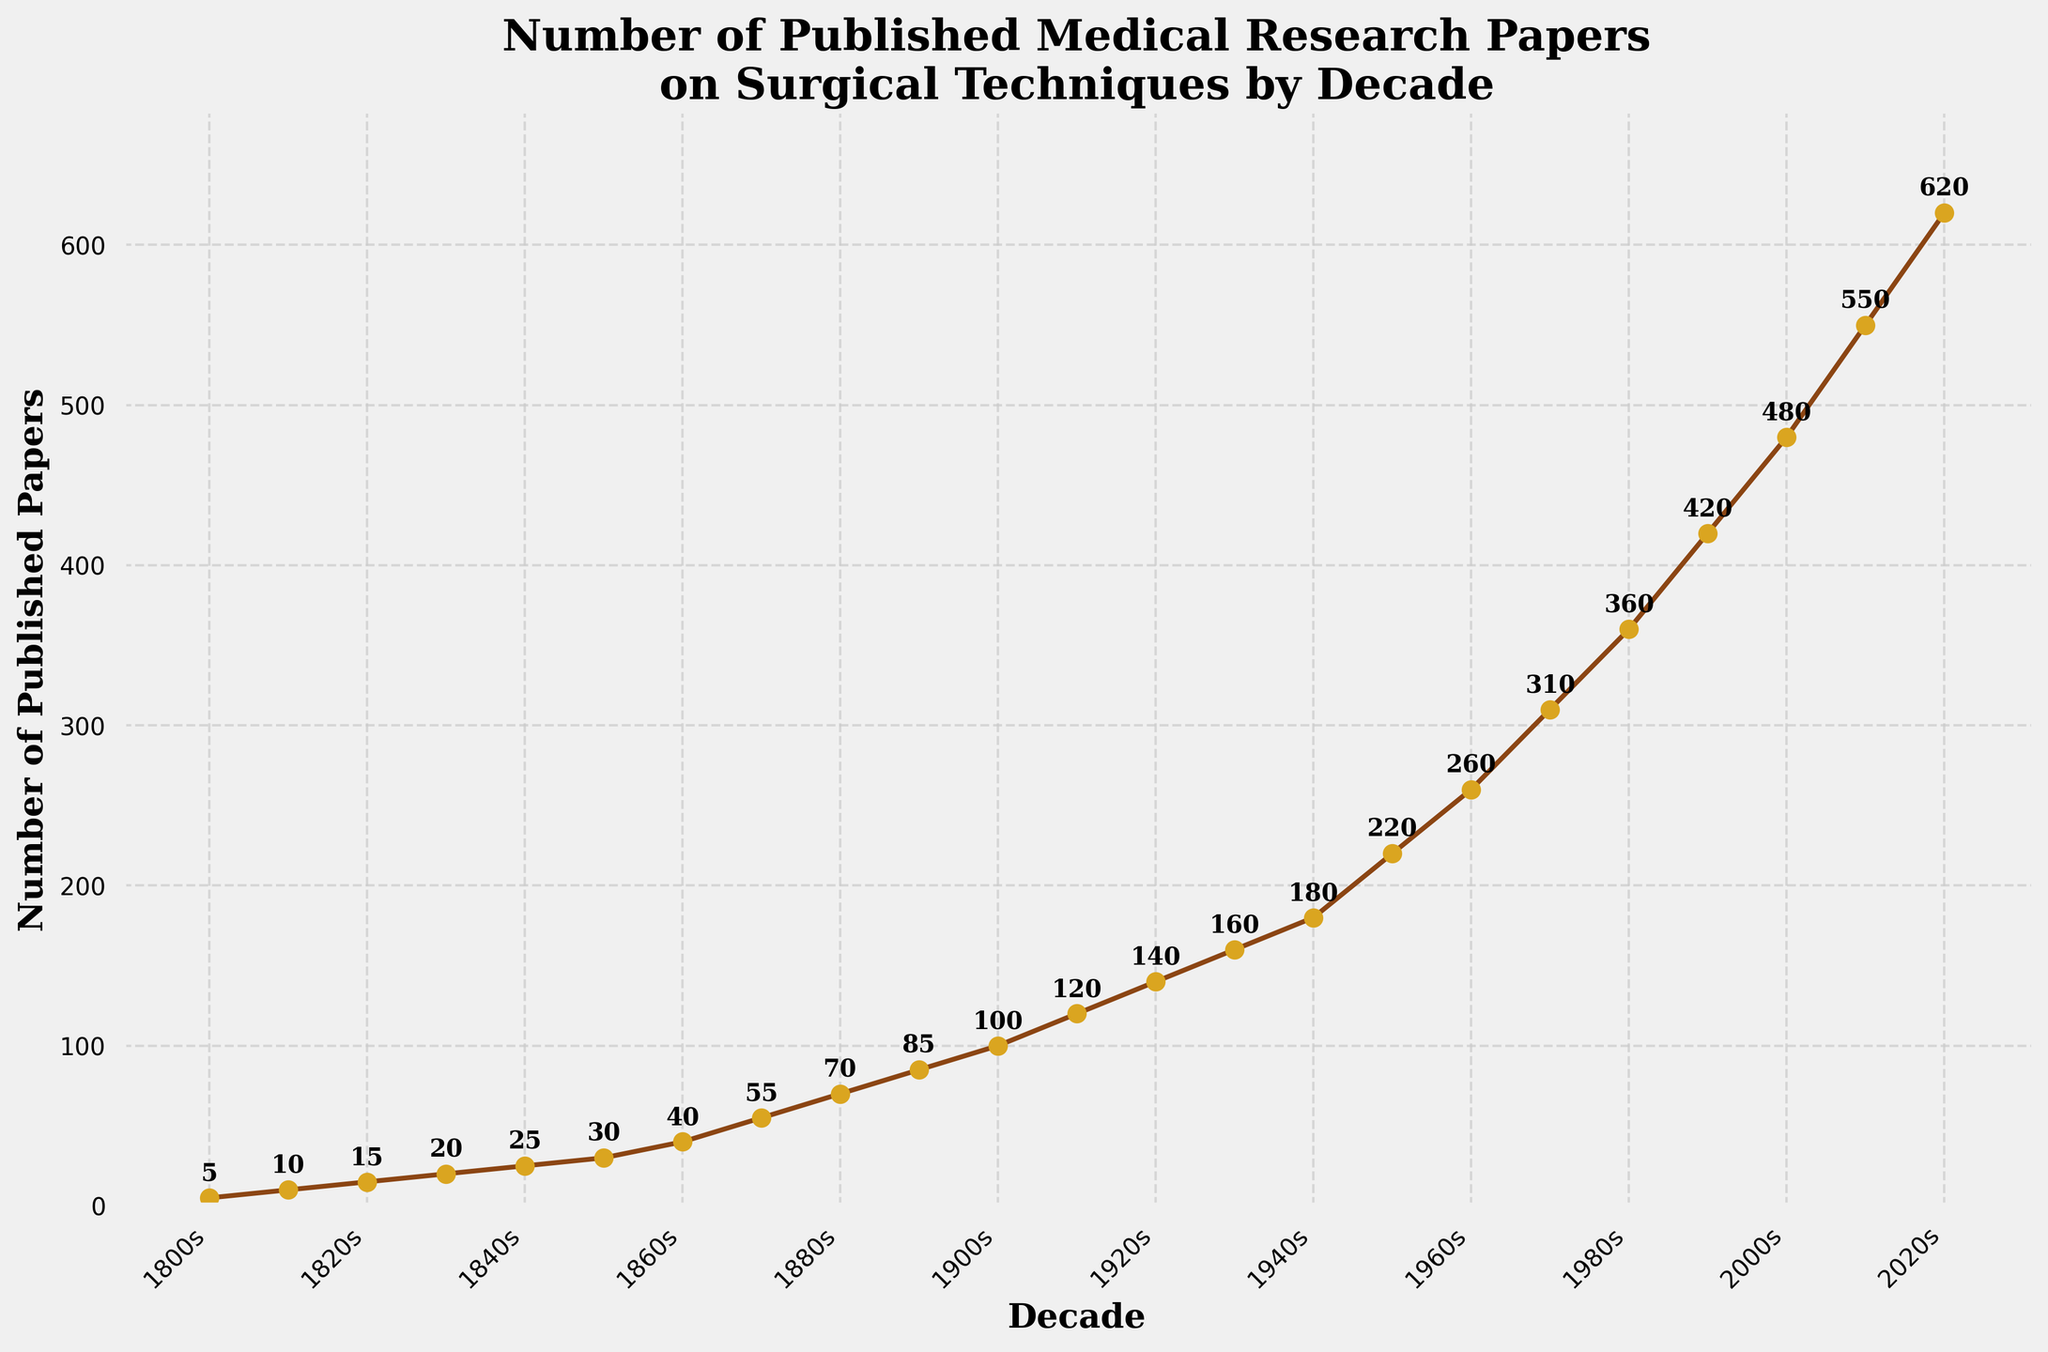What is the title of the figure? The title of the figure is displayed at the top and provides an overview of the visualization's content. It says "Number of Published Medical Research Papers on Surgical Techniques by Decade".
Answer: Number of Published Medical Research Papers on Surgical Techniques by Decade How does the number of published papers in the 1860s compare to the 1880s? In the 1860s, there were 40 published papers, and in the 1880s, there were 70. Subtracting the number in the 1860s from the 1880s gives 70 - 40 = 30 more papers published in the 1880s.
Answer: 30 more papers What is the trend in the number of published medical research papers from 1800 to 2020? The graph shows a steady increase in the number of published papers over the decades, indicating a consistent upward trend.
Answer: Upward trend In which decade did the number of published papers first exceed 100? By checking the graph, the number of published papers first exceeds 100 in the 1900s, where it reaches 100 papers exactly.
Answer: 1900s What was the total number of papers published from 1860s to 1920s? Summing the number of published papers from the 1860s (40), 1870s (55), 1880s (70), 1890s (85), 1900s (100), 1910s (120), and 1920s (140) gives 40 + 55 + 70 + 85 + 100 + 120 + 140 = 610.
Answer: 610 During which decade was there the greatest increase in the number of papers published compared to the previous decade? By calculating the differences for each decade and comparing them, the largest increase is found between the 2010s (550 papers) and the 2020s (620 papers), a difference of 620 - 550 = 70 papers.
Answer: 2010s to 2020s What is the difference in the number of papers published between the 1950s and 1970s? The number of papers in the 1950s is 220 and in the 1970s is 310. The difference is 310 - 220 = 90 papers.
Answer: 90 papers How many times more papers were published in the 2000s compared to the 1800s? There were 480 papers published in the 2000s and 5 in the 1800s. The multiplication factor is 480 / 5 = 96 times more papers.
Answer: 96 times What is the average number of papers published per decade from 1800s to 2020s? Summing the total number of published papers (sum of all values from 1800s to 2020s: 5 + 10 + 15 + 20 + 25 + 30 + 40 + 55 + 70 + 85 + 100 + 120 + 140 + 160 + 180 + 220 + 260 + 310 + 360 + 420 + 480 + 550 + 620 = 4275). Since there are 23 decades, the average is 4275 / 23 = 185.87.
Answer: 185.87 